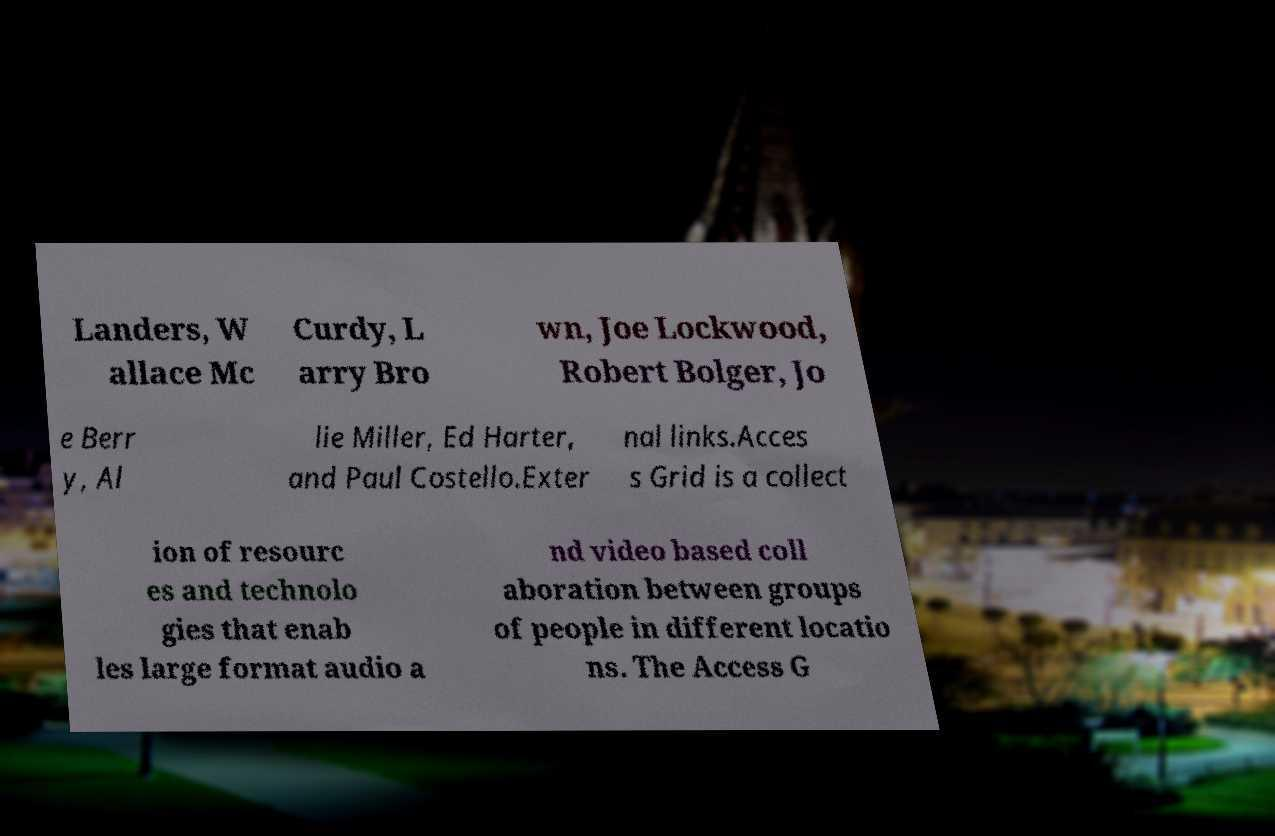Could you assist in decoding the text presented in this image and type it out clearly? Landers, W allace Mc Curdy, L arry Bro wn, Joe Lockwood, Robert Bolger, Jo e Berr y, Al lie Miller, Ed Harter, and Paul Costello.Exter nal links.Acces s Grid is a collect ion of resourc es and technolo gies that enab les large format audio a nd video based coll aboration between groups of people in different locatio ns. The Access G 